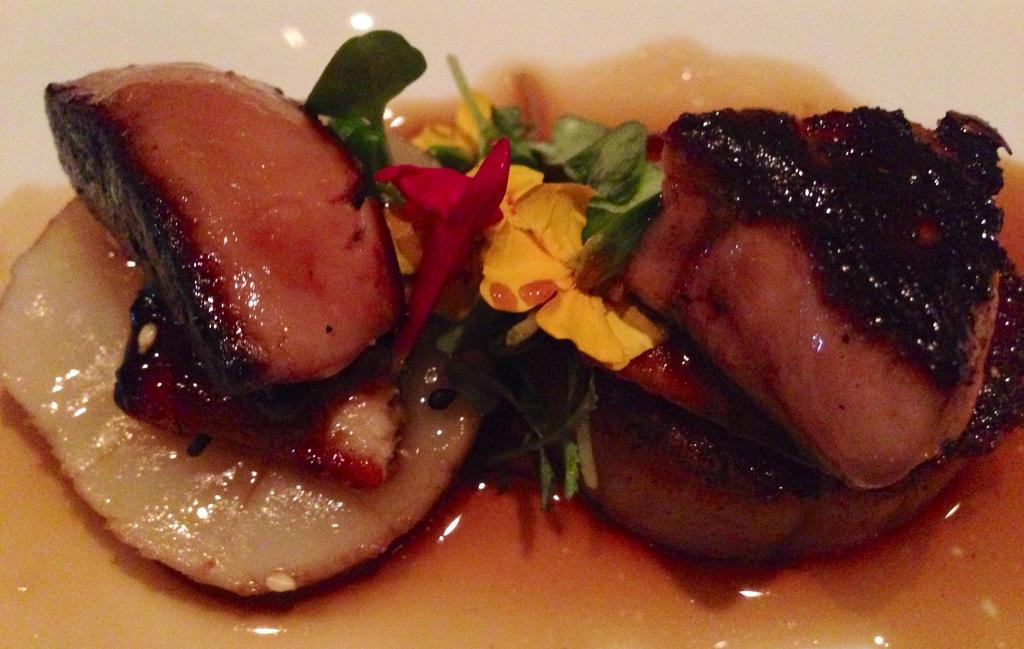What type of food is visible in the image? There is food in the image, but the specific type cannot be determined from the provided facts. What else is present in the image besides food? There are flowers and sauce visible in the image. What color is the sauce in the image? The sauce color cannot be determined from the provided facts. What is the color of the surface in the image? The surface in the image is white. How many ants are crawling on the head of the person in the image? There is no person or ants present in the image; it only contains food, flowers, and sauce on a white surface. 